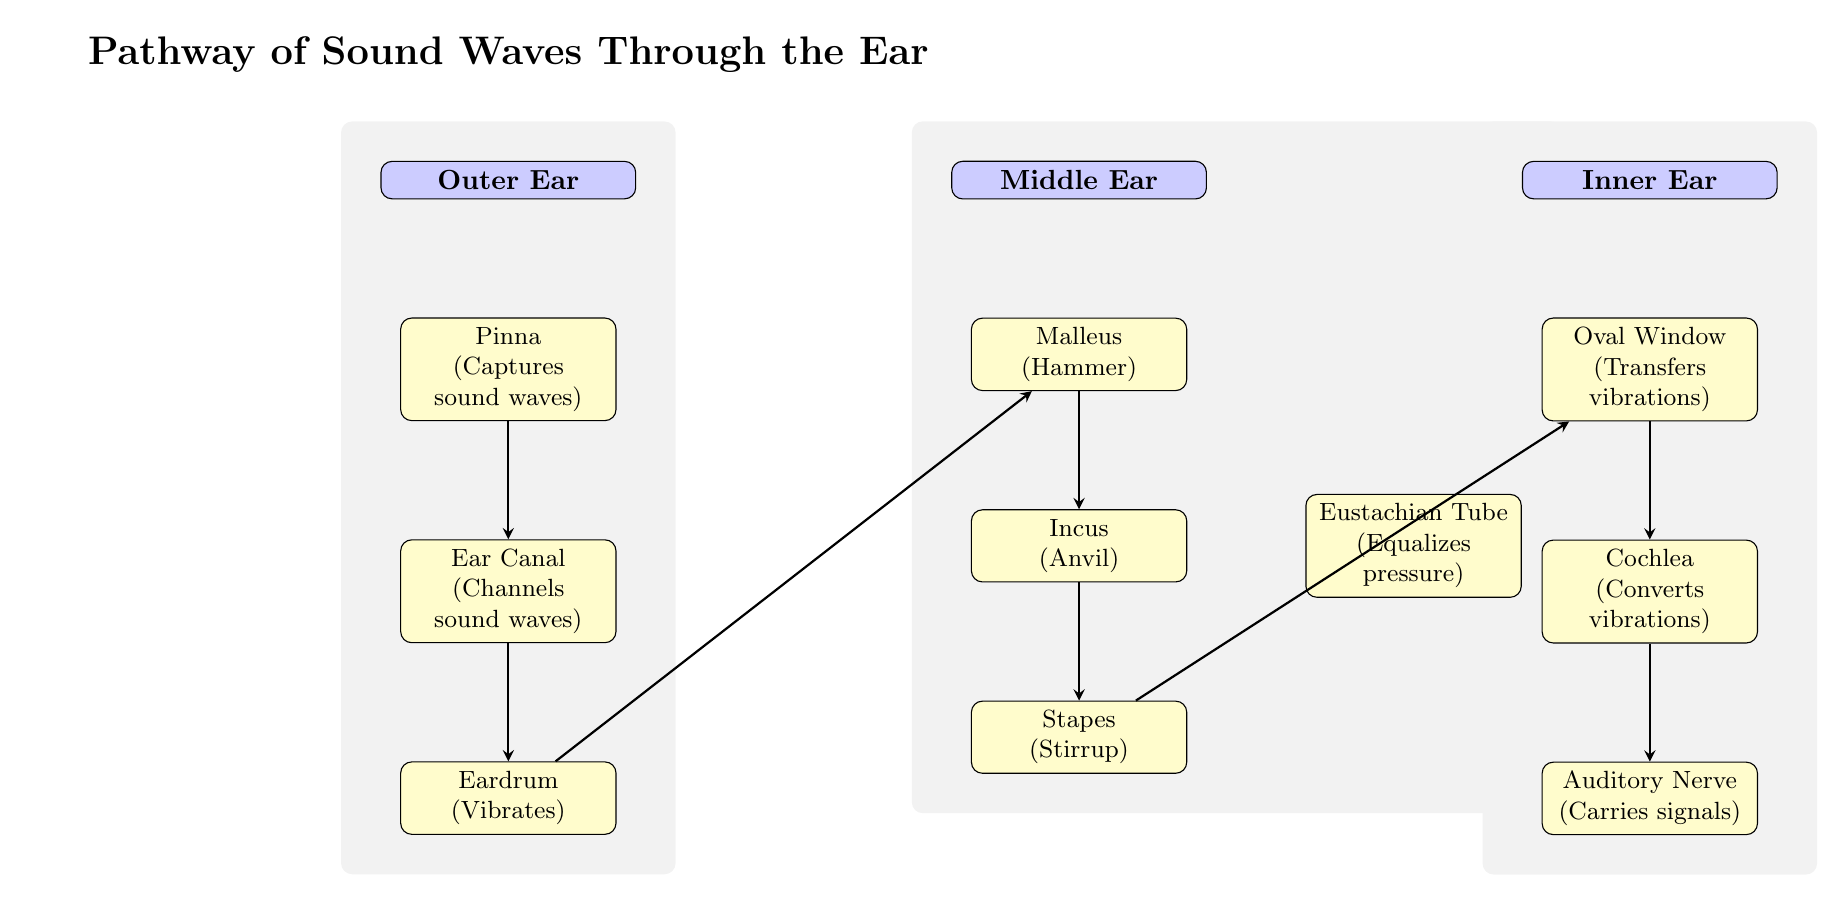What is the first structure sound waves encounter? According to the diagram, sound waves first encounter the Pinna, which is the outermost part of the ear. This is indicated as the first box under the "Outer Ear" section.
Answer: Pinna How many components are there in the Middle Ear? The Middle Ear section includes four components: Malleus, Incus, Stapes, and Eustachian Tube. Counting these boxes provides the total number.
Answer: 4 What transfers vibrations from the middle ear to the inner ear? The Stapes, which is illustrated as the last component in the Middle Ear section, transfers vibrations to the Oval Window in the Inner Ear.
Answer: Oval Window Which structure is responsible for converting vibrations into neural signals? The Cochlea, shown in the Inner Ear section, is responsible for converting the mechanical vibrations received into neural signals that can be interpreted by the brain.
Answer: Cochlea What pathway do sound waves follow from the eardrum to the auditory nerve? Sound waves travel from the Eardrum to the Malleus, then to the Incus, followed by the Stapes, moving to the Oval Window, then to the Cochlea, and finally to the Auditory Nerve. This sequence indicates the flow of sound from the outer structures to the inner workings of the ear.
Answer: Eardrum → Malleus → Incus → Stapes → Oval Window → Cochlea → Auditory Nerve What role does the Eustachian Tube play in the diagram? The Eustachian Tube, located in the Middle Ear section, is indicated to equalize pressure in the ear. This suggests its importance in maintaining the correct pressure necessary for proper hearing.
Answer: Equalizes pressure 